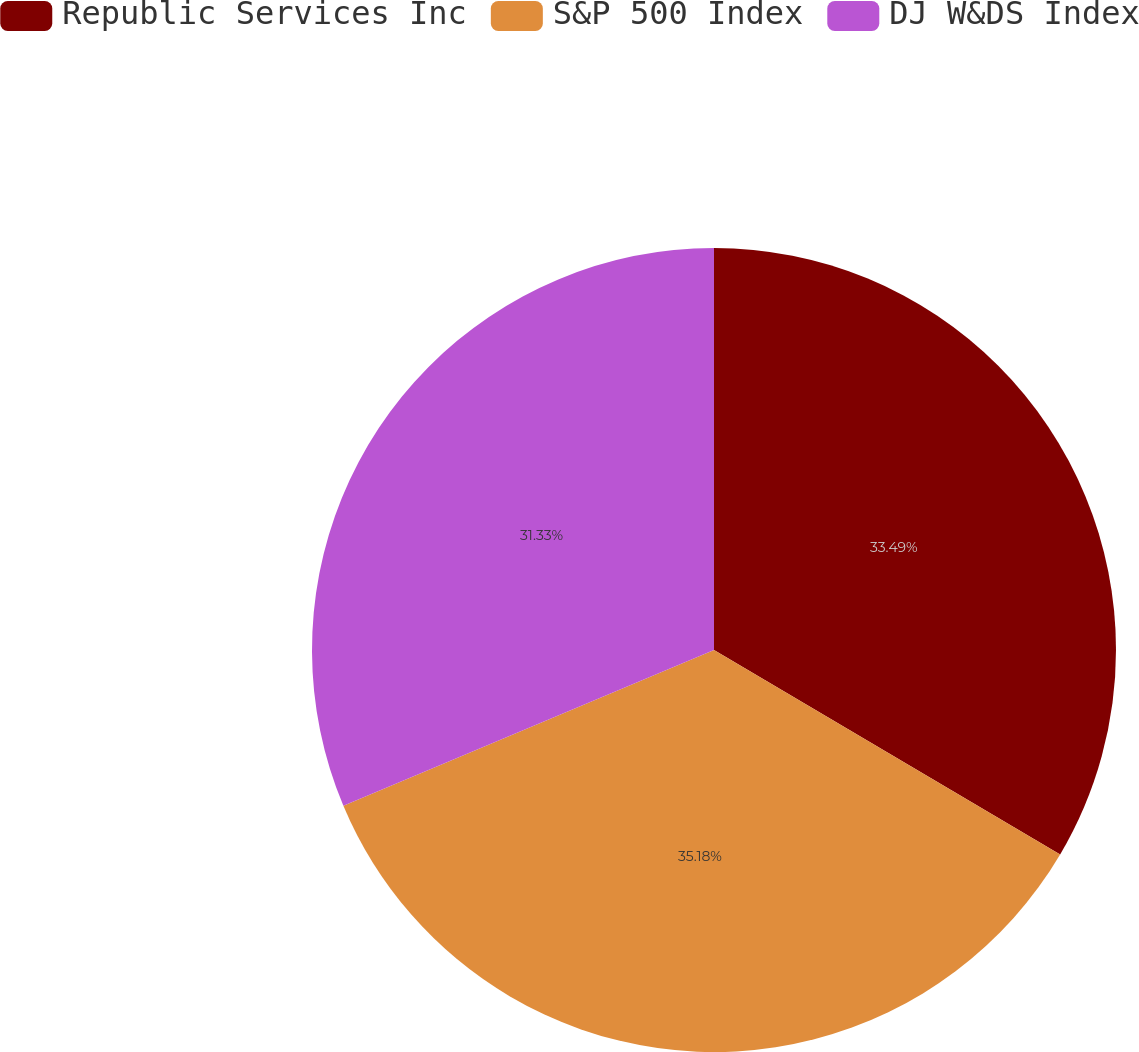Convert chart. <chart><loc_0><loc_0><loc_500><loc_500><pie_chart><fcel>Republic Services Inc<fcel>S&P 500 Index<fcel>DJ W&DS Index<nl><fcel>33.49%<fcel>35.18%<fcel>31.33%<nl></chart> 